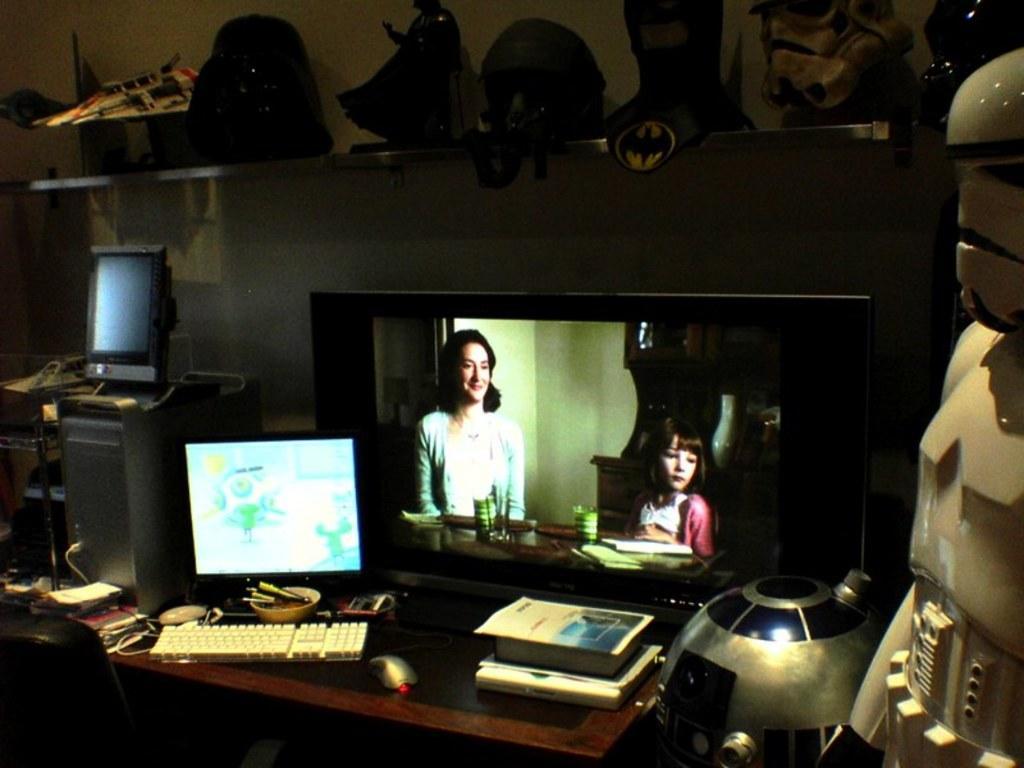Please provide a concise description of this image. In this image there are two screen on the table having keyboard, mouse, books on it. At the left side there is a CPU on it there is another monitor. Top of image there are few toys. At the right side there is a robot. 